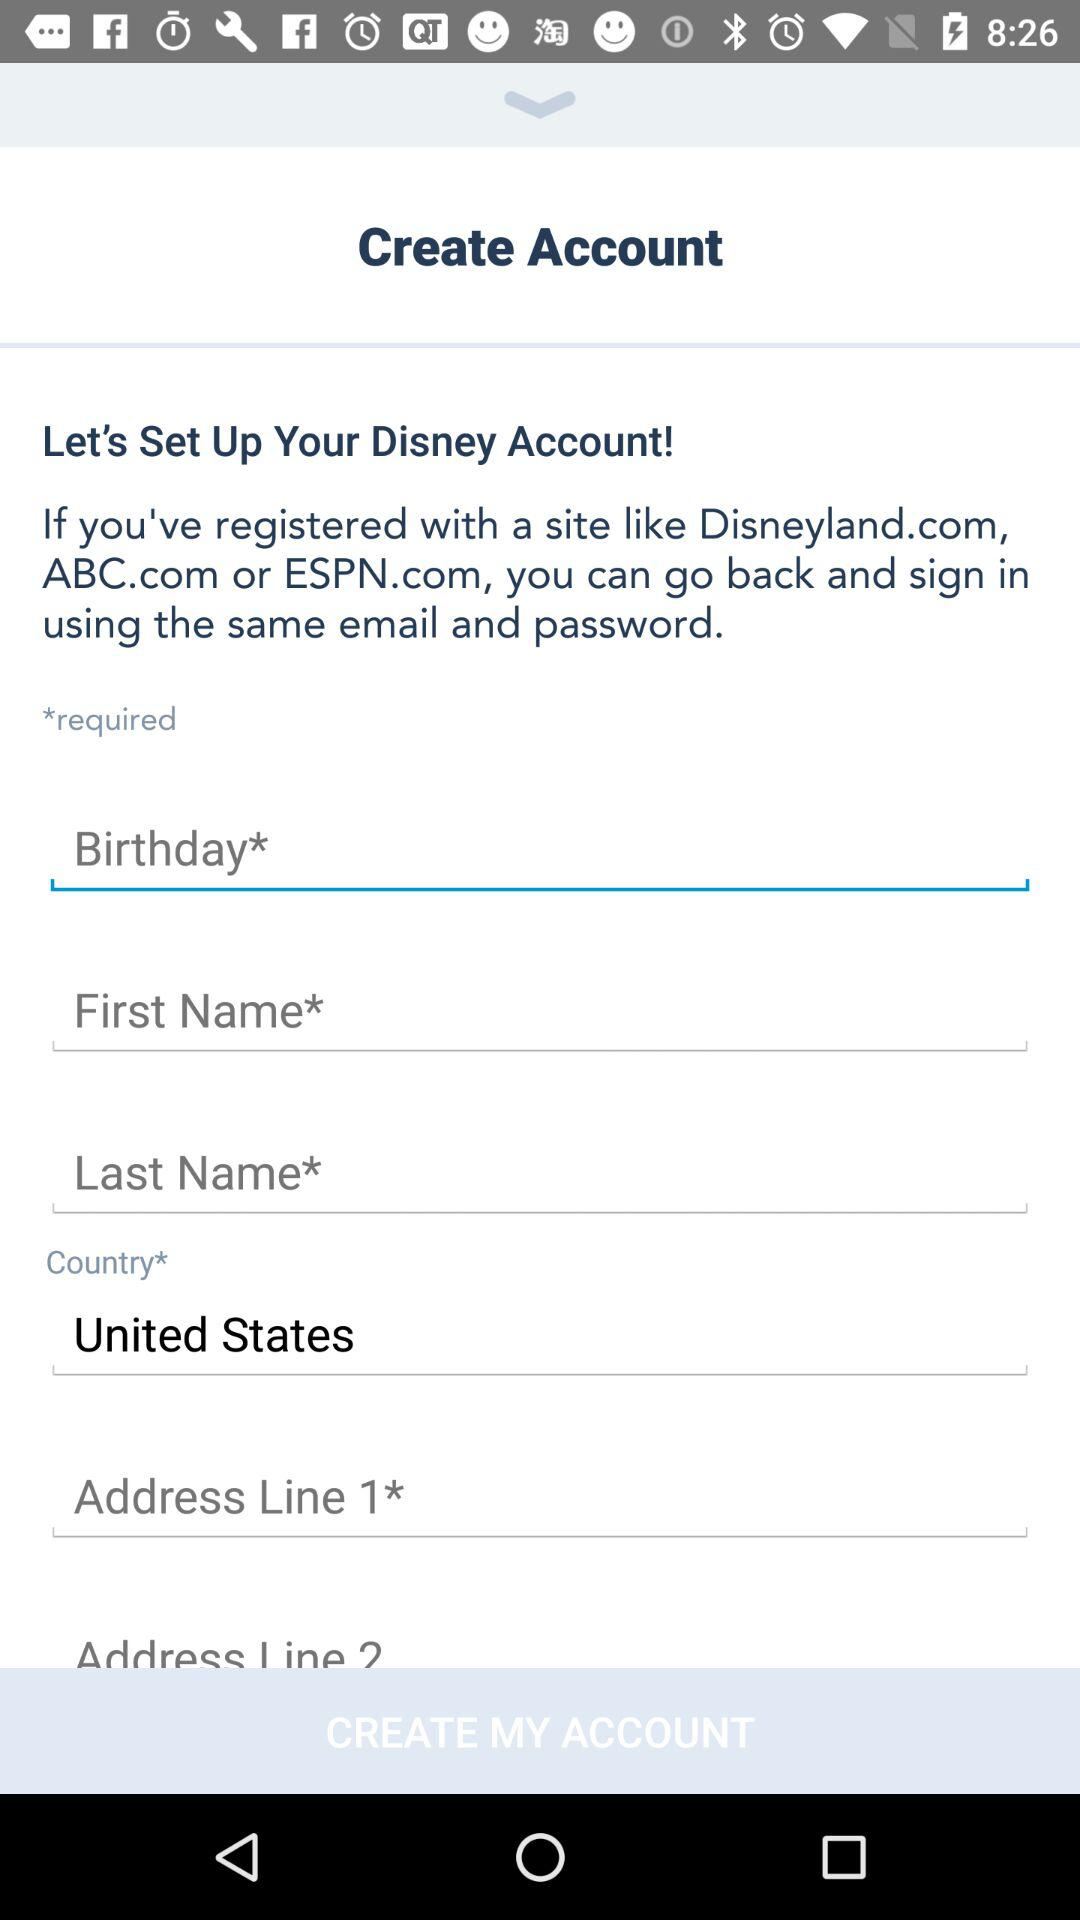How many text inputs require a value? 5 